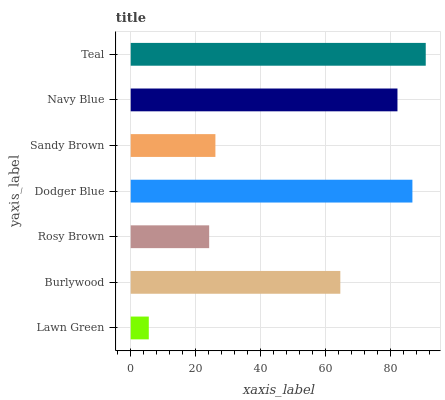Is Lawn Green the minimum?
Answer yes or no. Yes. Is Teal the maximum?
Answer yes or no. Yes. Is Burlywood the minimum?
Answer yes or no. No. Is Burlywood the maximum?
Answer yes or no. No. Is Burlywood greater than Lawn Green?
Answer yes or no. Yes. Is Lawn Green less than Burlywood?
Answer yes or no. Yes. Is Lawn Green greater than Burlywood?
Answer yes or no. No. Is Burlywood less than Lawn Green?
Answer yes or no. No. Is Burlywood the high median?
Answer yes or no. Yes. Is Burlywood the low median?
Answer yes or no. Yes. Is Rosy Brown the high median?
Answer yes or no. No. Is Teal the low median?
Answer yes or no. No. 